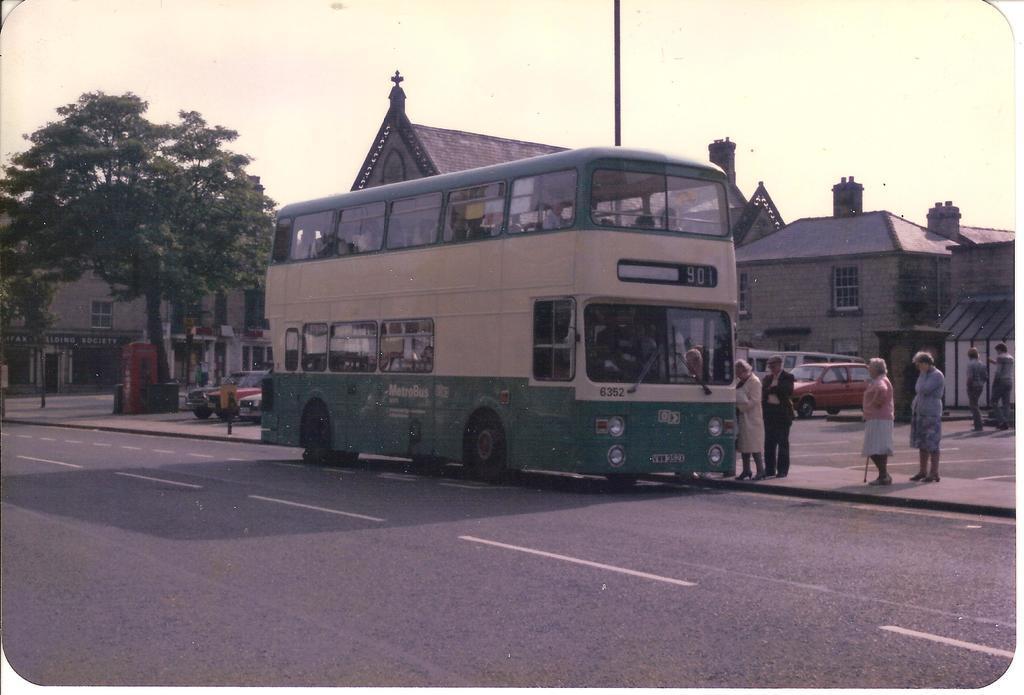Please provide a concise description of this image. In this image we can see some people standing, vehicles, buildings, trees, road and we can also see the sky. 